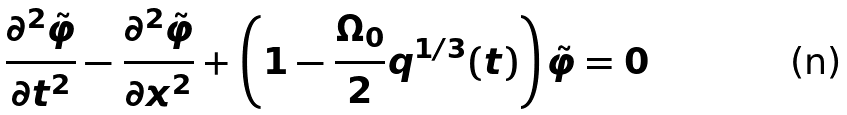Convert formula to latex. <formula><loc_0><loc_0><loc_500><loc_500>\frac { \partial ^ { 2 } \tilde { \varphi } } { \partial t ^ { 2 } } - \frac { \partial ^ { 2 } \tilde { \varphi } } { \partial x ^ { 2 } } + \left ( 1 - \frac { \Omega _ { 0 } } { 2 } q ^ { 1 / 3 } ( t ) \right ) \tilde { \varphi } = 0</formula> 